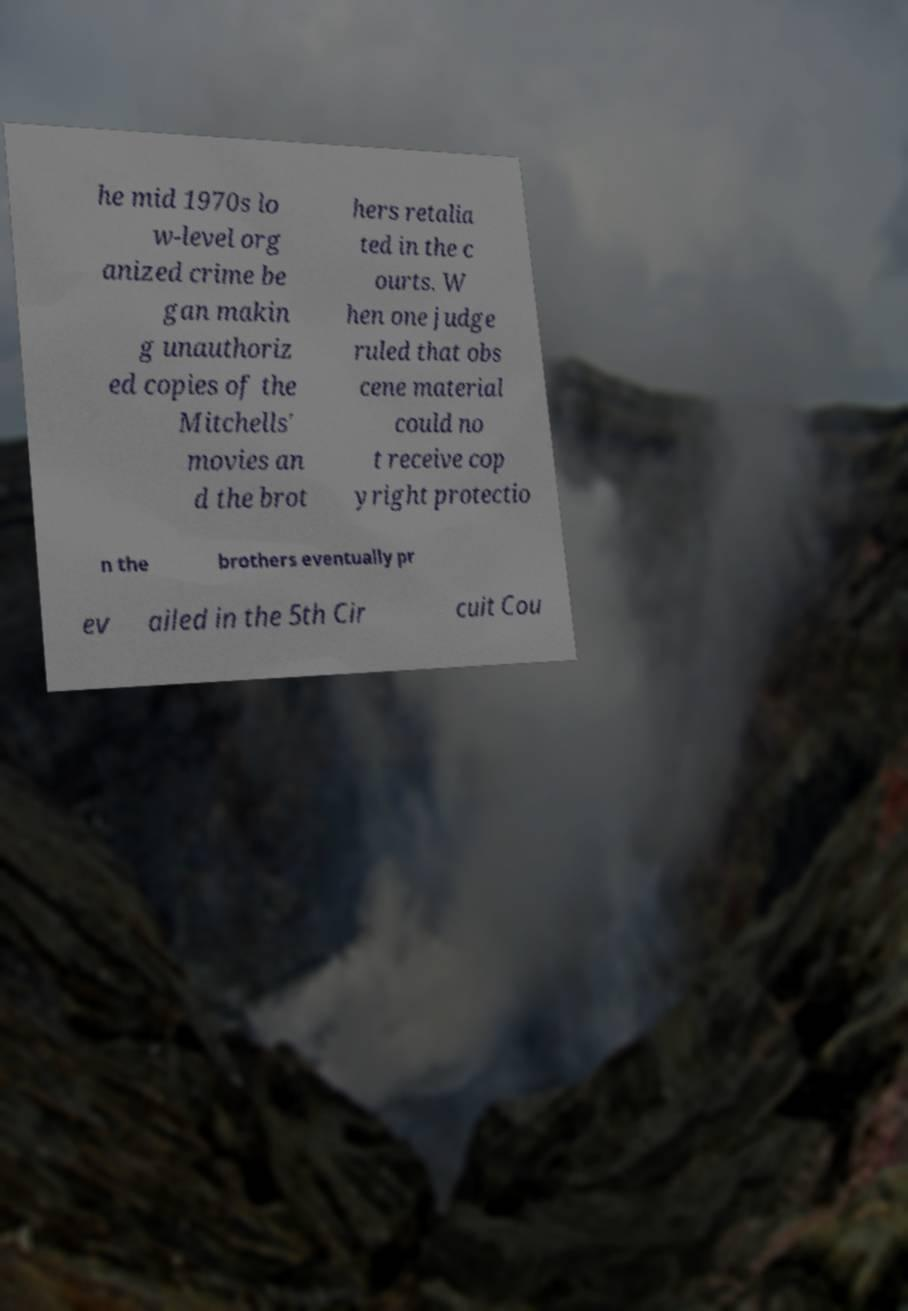Could you assist in decoding the text presented in this image and type it out clearly? he mid 1970s lo w-level org anized crime be gan makin g unauthoriz ed copies of the Mitchells' movies an d the brot hers retalia ted in the c ourts. W hen one judge ruled that obs cene material could no t receive cop yright protectio n the brothers eventually pr ev ailed in the 5th Cir cuit Cou 